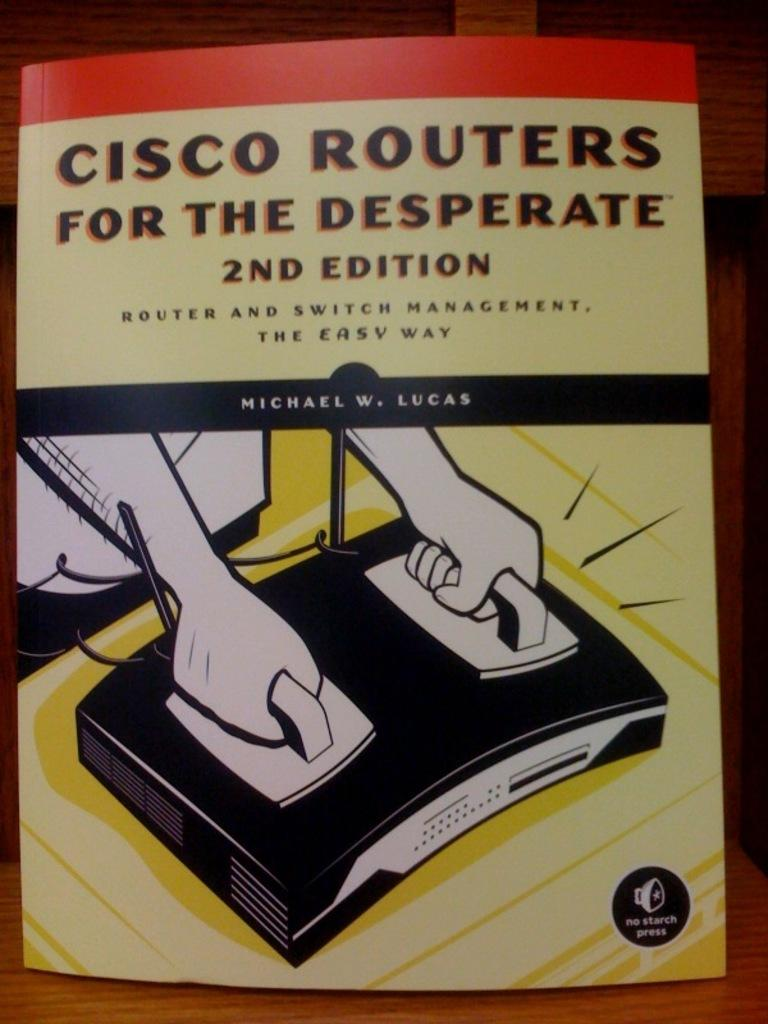<image>
Share a concise interpretation of the image provided. A book called Cisco Routers for the desperate has a clip art illustration of hands shocking a router. 